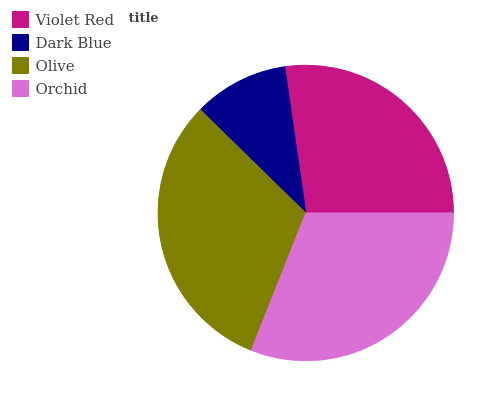Is Dark Blue the minimum?
Answer yes or no. Yes. Is Olive the maximum?
Answer yes or no. Yes. Is Olive the minimum?
Answer yes or no. No. Is Dark Blue the maximum?
Answer yes or no. No. Is Olive greater than Dark Blue?
Answer yes or no. Yes. Is Dark Blue less than Olive?
Answer yes or no. Yes. Is Dark Blue greater than Olive?
Answer yes or no. No. Is Olive less than Dark Blue?
Answer yes or no. No. Is Orchid the high median?
Answer yes or no. Yes. Is Violet Red the low median?
Answer yes or no. Yes. Is Dark Blue the high median?
Answer yes or no. No. Is Dark Blue the low median?
Answer yes or no. No. 